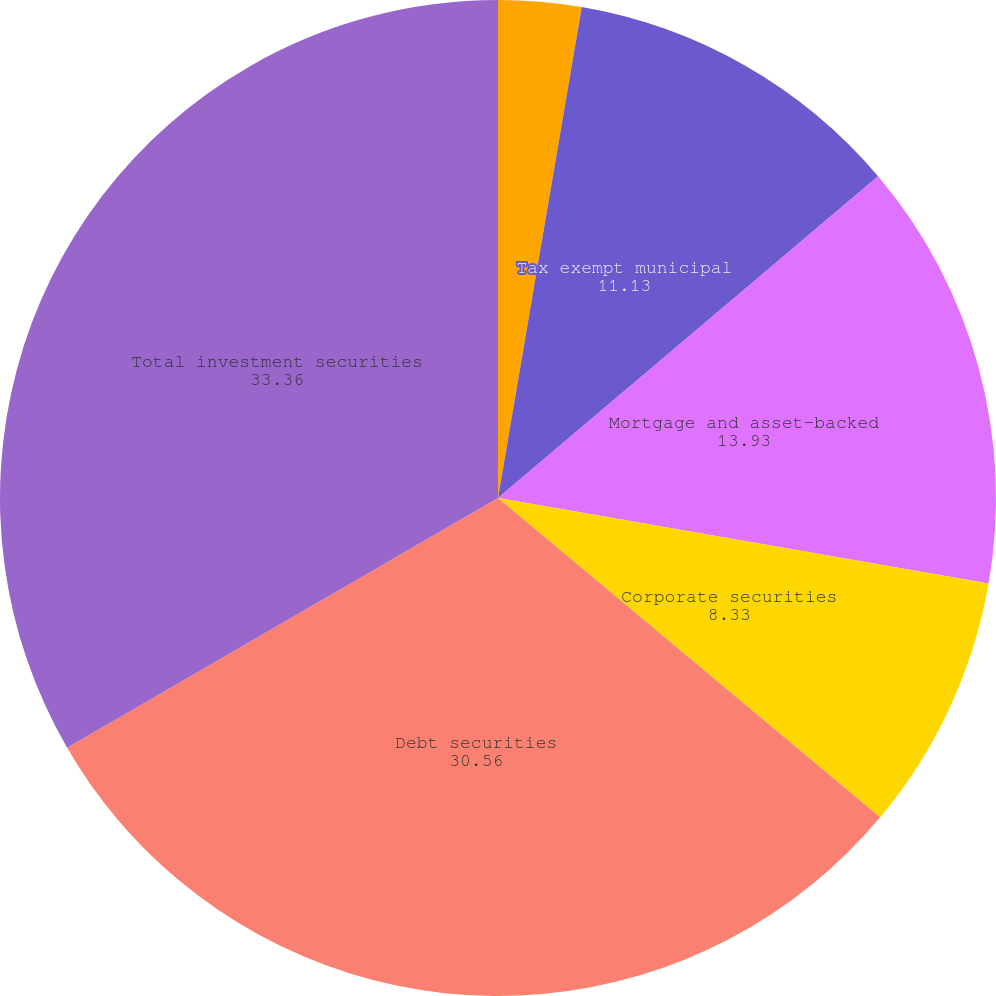Convert chart. <chart><loc_0><loc_0><loc_500><loc_500><pie_chart><fcel>US Government and agency<fcel>Tax exempt municipal<fcel>Mortgage and asset-backed<fcel>Corporate securities<fcel>Debt securities<fcel>Total investment securities<nl><fcel>2.69%<fcel>11.13%<fcel>13.93%<fcel>8.33%<fcel>30.56%<fcel>33.36%<nl></chart> 